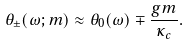Convert formula to latex. <formula><loc_0><loc_0><loc_500><loc_500>\theta _ { \pm } ( \omega ; m ) \approx \theta _ { 0 } ( \omega ) \mp \frac { g m } { \kappa _ { c } } .</formula> 